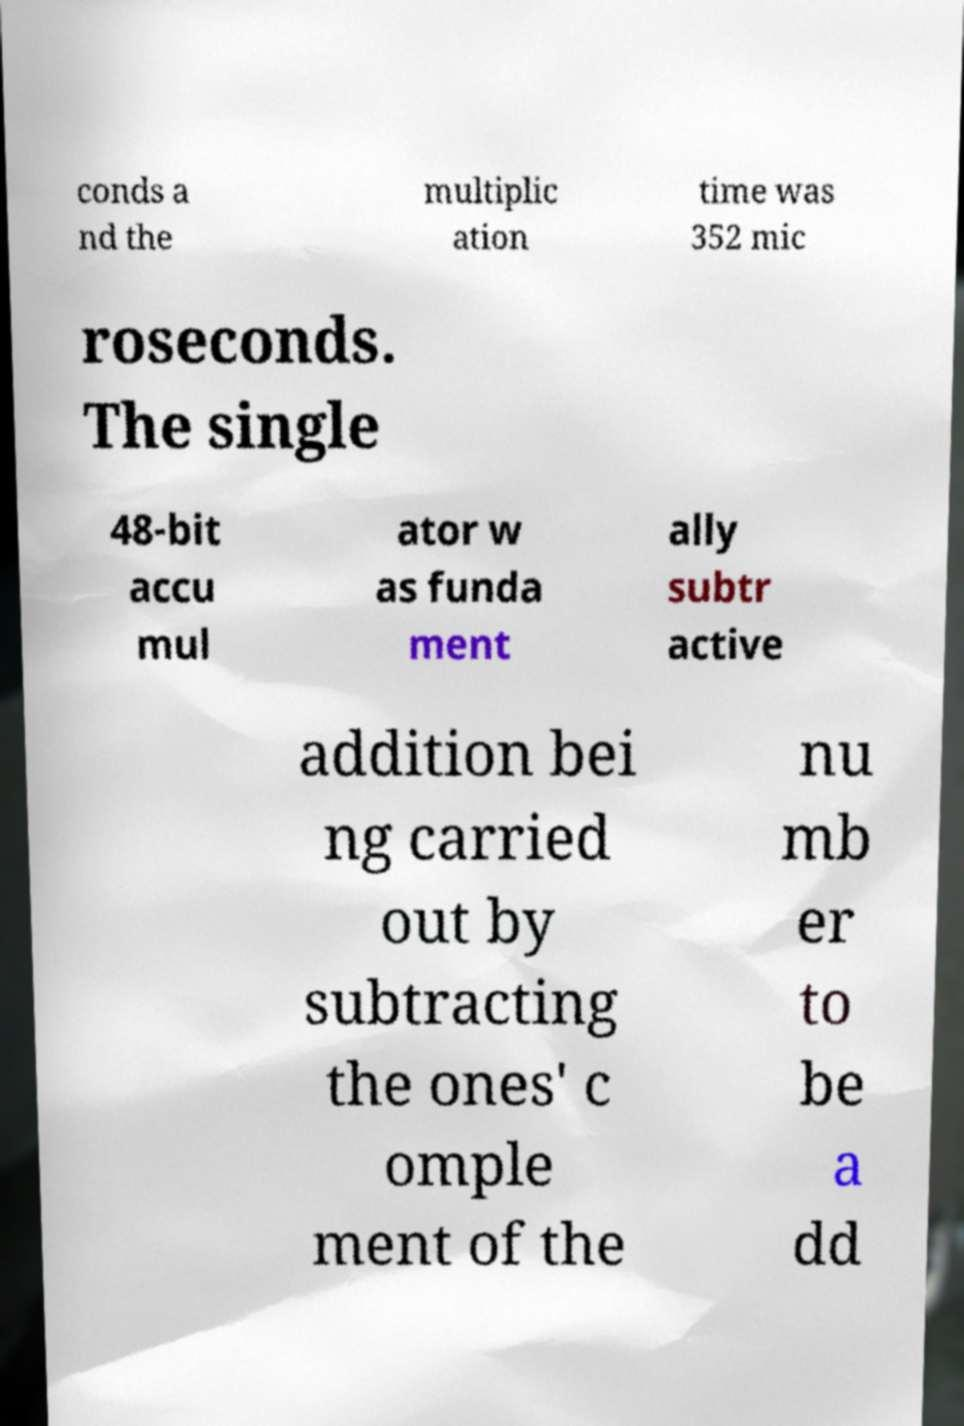Could you extract and type out the text from this image? conds a nd the multiplic ation time was 352 mic roseconds. The single 48-bit accu mul ator w as funda ment ally subtr active addition bei ng carried out by subtracting the ones' c omple ment of the nu mb er to be a dd 